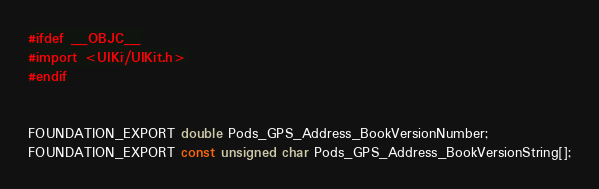Convert code to text. <code><loc_0><loc_0><loc_500><loc_500><_C_>#ifdef __OBJC__
#import <UIKit/UIKit.h>
#endif


FOUNDATION_EXPORT double Pods_GPS_Address_BookVersionNumber;
FOUNDATION_EXPORT const unsigned char Pods_GPS_Address_BookVersionString[];

</code> 